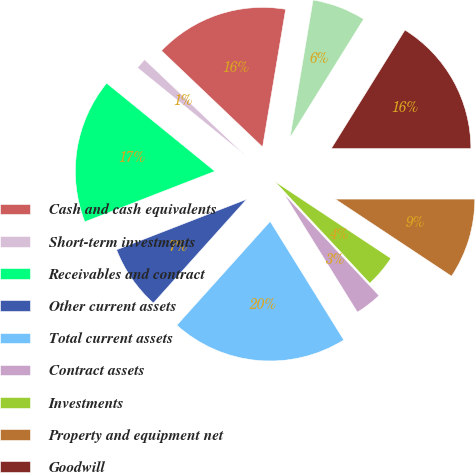Convert chart to OTSL. <chart><loc_0><loc_0><loc_500><loc_500><pie_chart><fcel>Cash and cash equivalents<fcel>Short-term investments<fcel>Receivables and contract<fcel>Other current assets<fcel>Total current assets<fcel>Contract assets<fcel>Investments<fcel>Property and equipment net<fcel>Goodwill<fcel>Deferred contract costs<nl><fcel>15.53%<fcel>1.24%<fcel>16.77%<fcel>7.45%<fcel>20.5%<fcel>3.11%<fcel>3.73%<fcel>9.32%<fcel>16.15%<fcel>6.21%<nl></chart> 